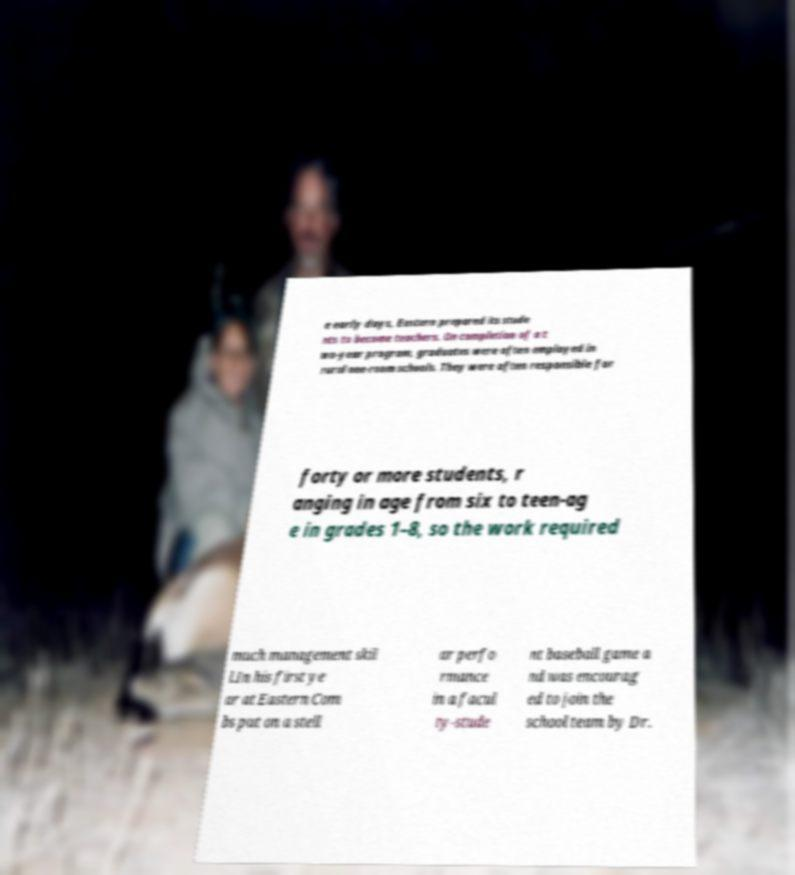Please read and relay the text visible in this image. What does it say? e early days, Eastern prepared its stude nts to become teachers. On completion of a t wo-year program, graduates were often employed in rural one-room schools. They were often responsible for forty or more students, r anging in age from six to teen-ag e in grades 1–8, so the work required much management skil l.In his first ye ar at Eastern Com bs put on a stell ar perfo rmance in a facul ty-stude nt baseball game a nd was encourag ed to join the school team by Dr. 